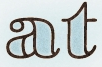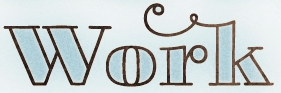What words can you see in these images in sequence, separated by a semicolon? at; work 